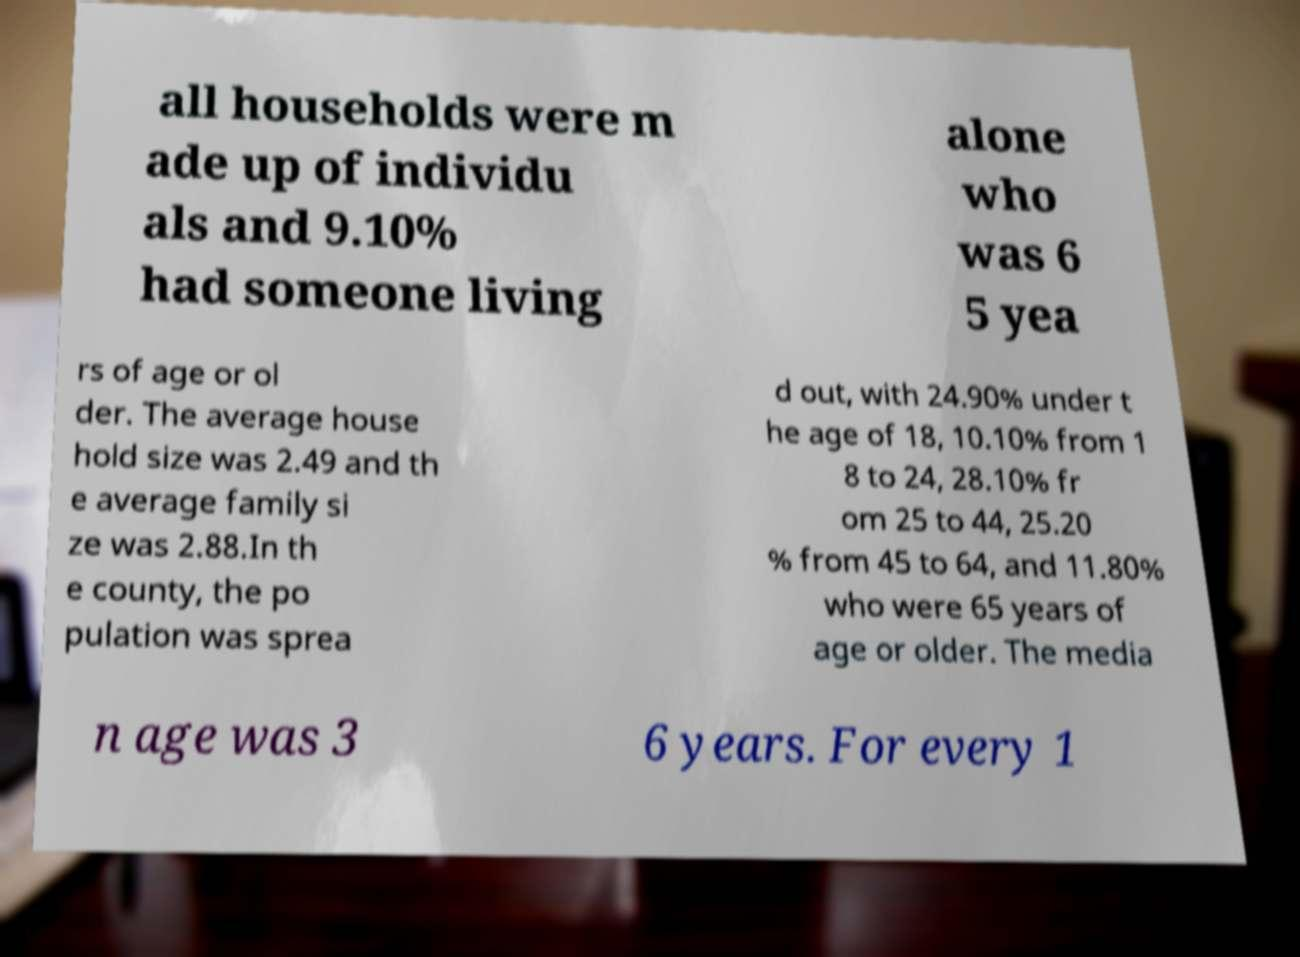There's text embedded in this image that I need extracted. Can you transcribe it verbatim? all households were m ade up of individu als and 9.10% had someone living alone who was 6 5 yea rs of age or ol der. The average house hold size was 2.49 and th e average family si ze was 2.88.In th e county, the po pulation was sprea d out, with 24.90% under t he age of 18, 10.10% from 1 8 to 24, 28.10% fr om 25 to 44, 25.20 % from 45 to 64, and 11.80% who were 65 years of age or older. The media n age was 3 6 years. For every 1 